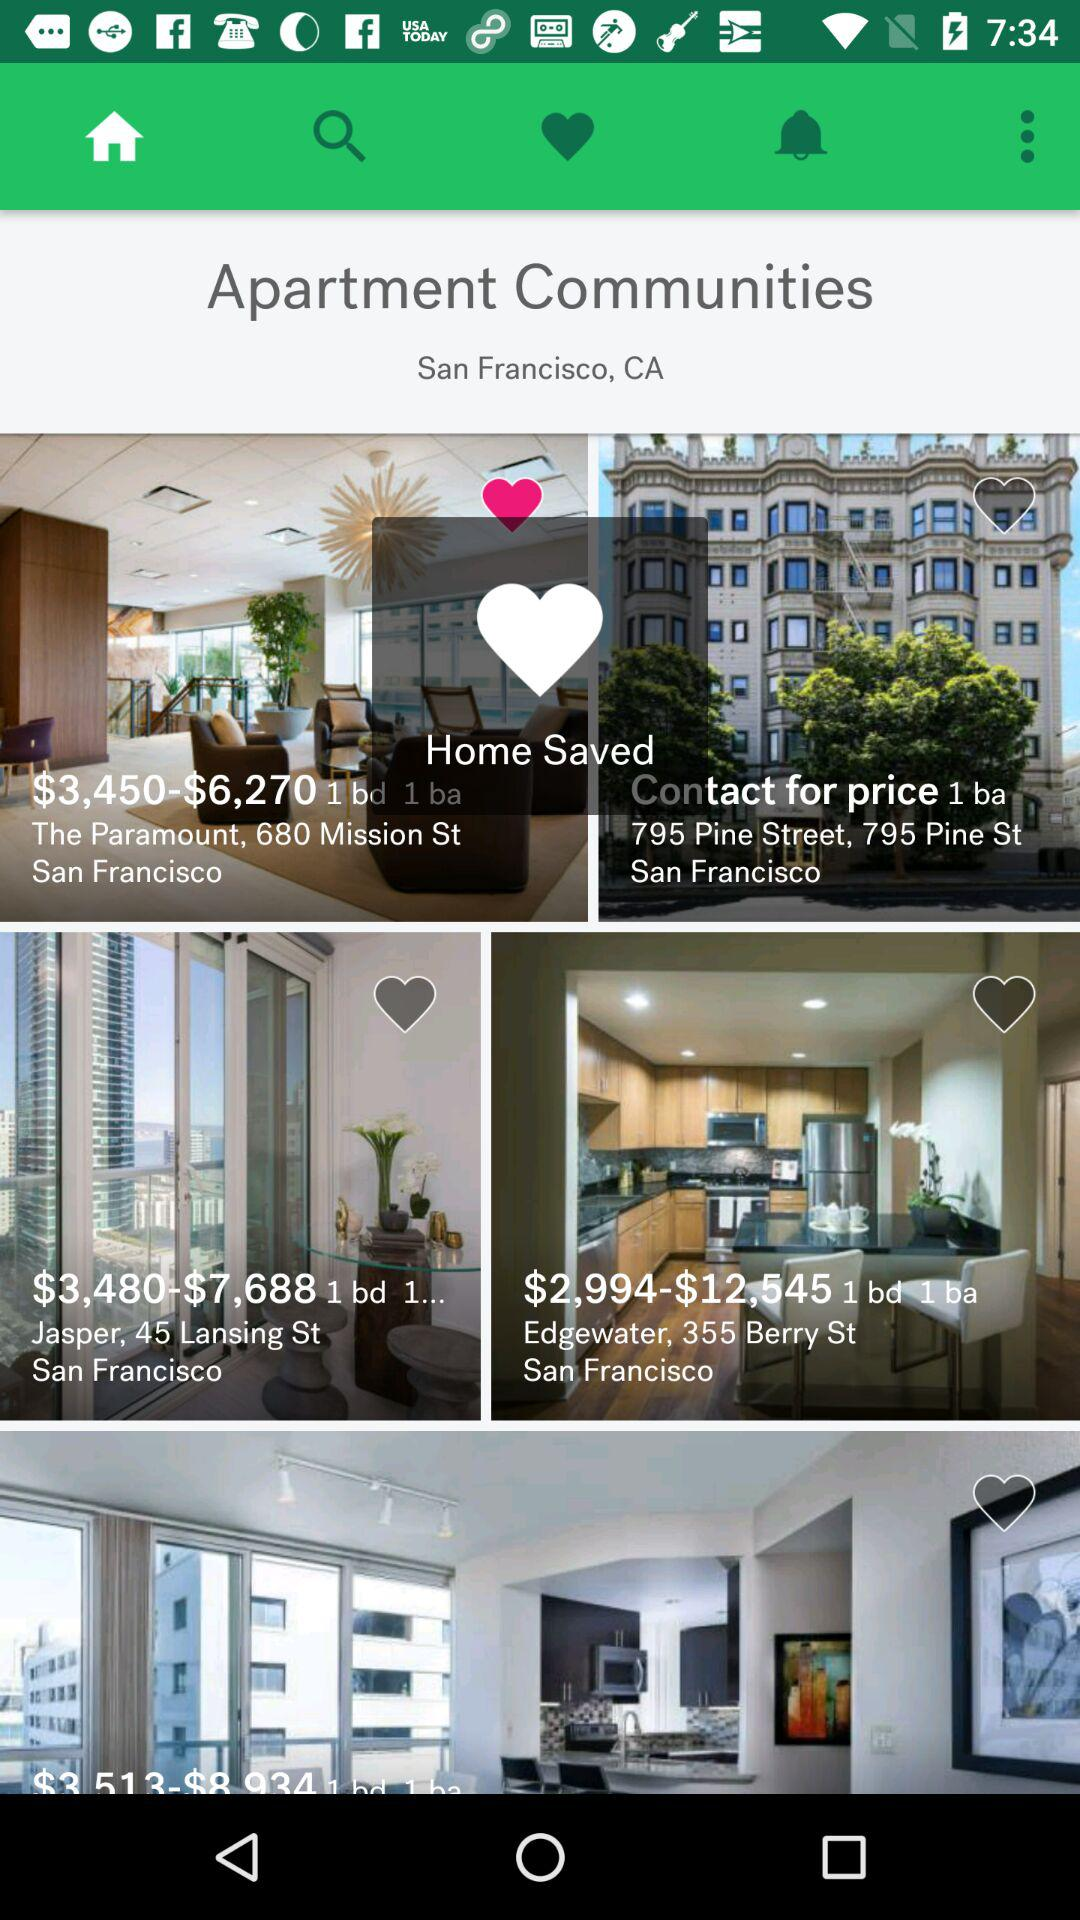In what location these apartment are located? The location is San Francisco, CA. 